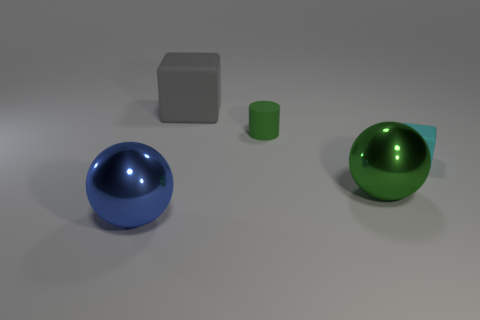There is a cyan cube; are there any objects in front of it?
Give a very brief answer. Yes. What is the color of the big metallic ball that is in front of the shiny thing behind the shiny object left of the gray matte thing?
Your answer should be very brief. Blue. What shape is the rubber object that is the same size as the green shiny object?
Ensure brevity in your answer.  Cube. Are there more big purple metallic cylinders than small rubber cylinders?
Provide a succinct answer. No. There is a large thing that is in front of the big green object; is there a big blue thing behind it?
Give a very brief answer. No. What is the color of the other big matte thing that is the same shape as the cyan matte thing?
Your answer should be very brief. Gray. Are there any other things that have the same shape as the big blue object?
Offer a very short reply. Yes. What color is the cylinder that is the same material as the small cyan cube?
Make the answer very short. Green. Is there a rubber thing in front of the matte cube that is in front of the thing that is behind the tiny green matte thing?
Keep it short and to the point. No. Are there fewer green things that are left of the large blue object than green balls in front of the green ball?
Make the answer very short. No. 